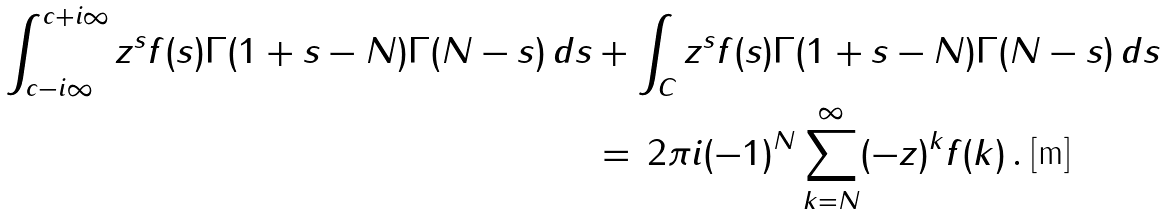<formula> <loc_0><loc_0><loc_500><loc_500>\int _ { c - i \infty } ^ { c + i \infty } z ^ { s } f ( s ) \Gamma ( 1 + s - N ) \Gamma ( N - s ) \, d s & + \int _ { C } z ^ { s } f ( s ) \Gamma ( 1 + s - N ) \Gamma ( N - s ) \, d s \\ & = \, 2 \pi i ( - 1 ) ^ { N } \sum _ { k = N } ^ { \infty } ( - z ) ^ { k } f ( k ) \, .</formula> 